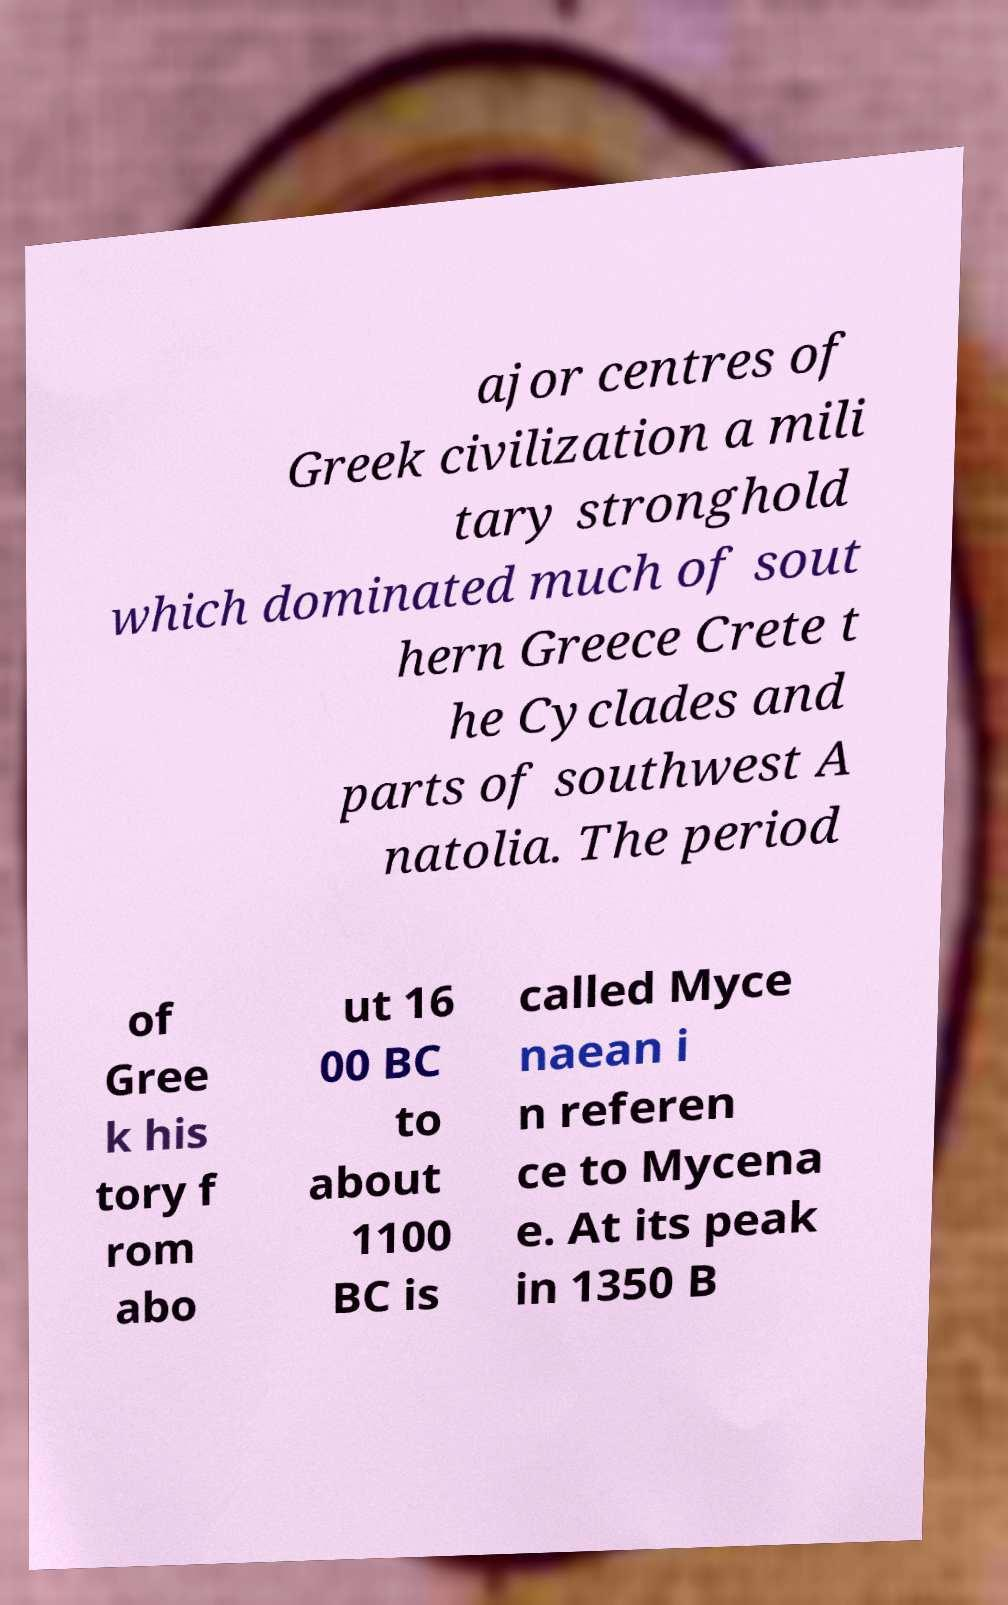For documentation purposes, I need the text within this image transcribed. Could you provide that? ajor centres of Greek civilization a mili tary stronghold which dominated much of sout hern Greece Crete t he Cyclades and parts of southwest A natolia. The period of Gree k his tory f rom abo ut 16 00 BC to about 1100 BC is called Myce naean i n referen ce to Mycena e. At its peak in 1350 B 